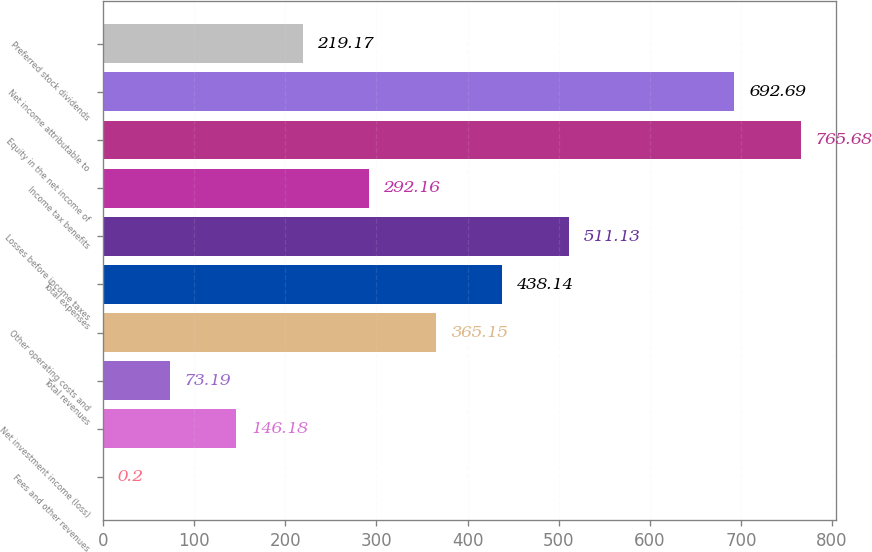<chart> <loc_0><loc_0><loc_500><loc_500><bar_chart><fcel>Fees and other revenues<fcel>Net investment income (loss)<fcel>Total revenues<fcel>Other operating costs and<fcel>Total expenses<fcel>Losses before income taxes<fcel>Income tax benefits<fcel>Equity in the net income of<fcel>Net income attributable to<fcel>Preferred stock dividends<nl><fcel>0.2<fcel>146.18<fcel>73.19<fcel>365.15<fcel>438.14<fcel>511.13<fcel>292.16<fcel>765.68<fcel>692.69<fcel>219.17<nl></chart> 